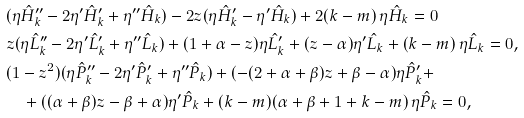<formula> <loc_0><loc_0><loc_500><loc_500>& ( \eta \hat { H } _ { k } ^ { \prime \prime } - 2 \eta ^ { \prime } \hat { H } _ { k } ^ { \prime } + \eta ^ { \prime \prime } \hat { H } _ { k } ) - 2 z ( \eta \hat { H } _ { k } ^ { \prime } - \eta ^ { \prime } \hat { H } _ { k } ) + 2 ( k - m ) \, \eta \hat { H } _ { k } = 0 \\ & z ( \eta \hat { L } _ { k } ^ { \prime \prime } - 2 \eta ^ { \prime } \hat { L } _ { k } ^ { \prime } + \eta ^ { \prime \prime } \hat { L } _ { k } ) + ( 1 + \alpha - z ) \eta \hat { L } _ { k } ^ { \prime } + ( z - \alpha ) \eta ^ { \prime } \hat { L } _ { k } + ( k - m ) \, \eta \hat { L } _ { k } = 0 , \\ & ( 1 - z ^ { 2 } ) ( \eta \hat { P } _ { k } ^ { \prime \prime } - 2 \eta ^ { \prime } \hat { P } _ { k } ^ { \prime } + \eta ^ { \prime \prime } \hat { P } _ { k } ) + ( - ( 2 + \alpha + \beta ) z + \beta - \alpha ) \eta \hat { P } _ { k } ^ { \prime } + \\ & \quad + ( ( \alpha + \beta ) z - \beta + \alpha ) \eta ^ { \prime } \hat { P } _ { k } + ( k - m ) ( \alpha + \beta + 1 + k - m ) \, \eta \hat { P } _ { k } = 0 ,</formula> 